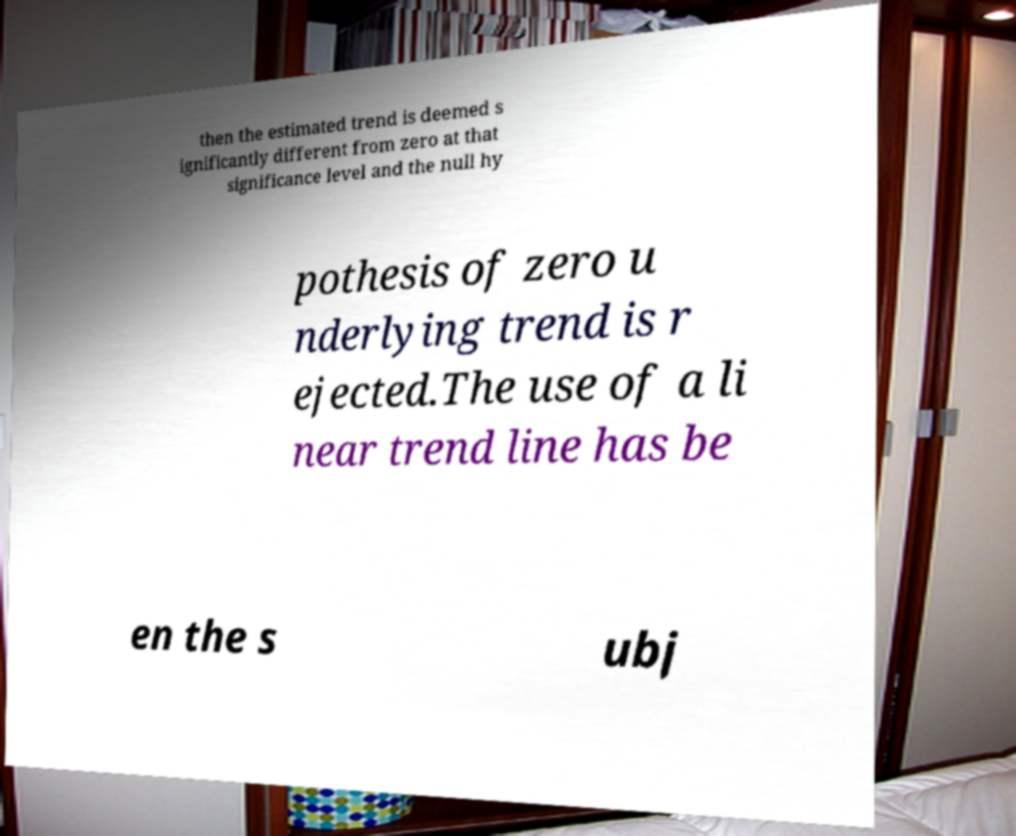I need the written content from this picture converted into text. Can you do that? then the estimated trend is deemed s ignificantly different from zero at that significance level and the null hy pothesis of zero u nderlying trend is r ejected.The use of a li near trend line has be en the s ubj 